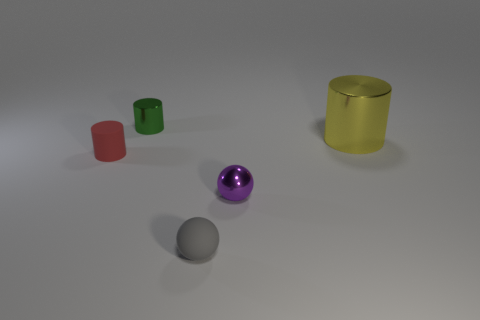Add 4 red things. How many objects exist? 9 Subtract 1 cylinders. How many cylinders are left? 2 Subtract all small cylinders. How many cylinders are left? 1 Subtract all spheres. How many objects are left? 3 Subtract all purple cylinders. Subtract all blue spheres. How many cylinders are left? 3 Subtract all small red matte things. Subtract all yellow objects. How many objects are left? 3 Add 2 red rubber objects. How many red rubber objects are left? 3 Add 5 purple rubber spheres. How many purple rubber spheres exist? 5 Subtract 0 blue cylinders. How many objects are left? 5 